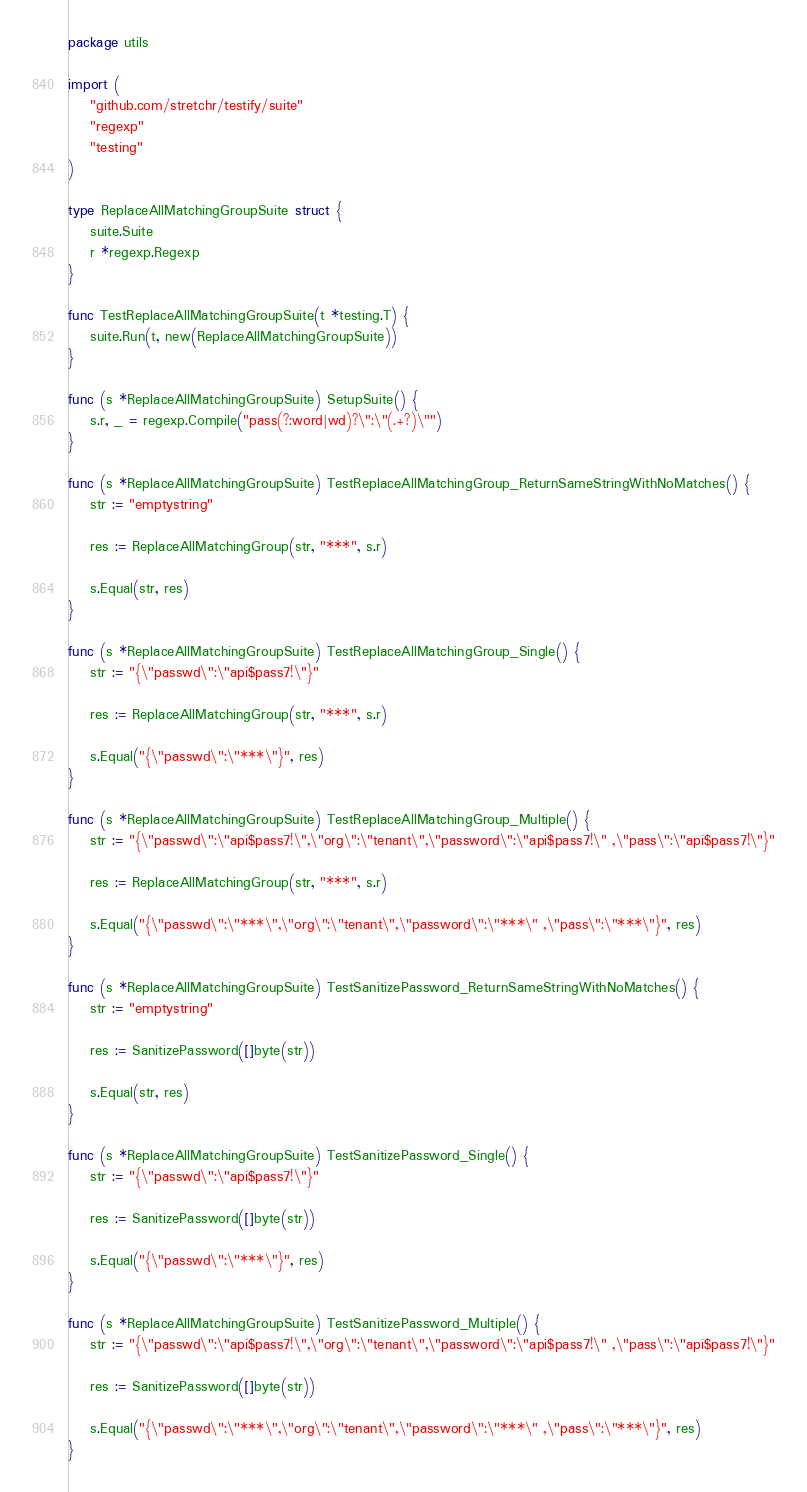<code> <loc_0><loc_0><loc_500><loc_500><_Go_>package utils

import (
	"github.com/stretchr/testify/suite"
	"regexp"
	"testing"
)

type ReplaceAllMatchingGroupSuite struct {
	suite.Suite
	r *regexp.Regexp
}

func TestReplaceAllMatchingGroupSuite(t *testing.T) {
	suite.Run(t, new(ReplaceAllMatchingGroupSuite))
}

func (s *ReplaceAllMatchingGroupSuite) SetupSuite() {
	s.r, _ = regexp.Compile("pass(?:word|wd)?\":\"(.+?)\"")
}

func (s *ReplaceAllMatchingGroupSuite) TestReplaceAllMatchingGroup_ReturnSameStringWithNoMatches() {
	str := "emptystring"

	res := ReplaceAllMatchingGroup(str, "***", s.r)

	s.Equal(str, res)
}

func (s *ReplaceAllMatchingGroupSuite) TestReplaceAllMatchingGroup_Single() {
	str := "{\"passwd\":\"api$pass7!\"}"

	res := ReplaceAllMatchingGroup(str, "***", s.r)

	s.Equal("{\"passwd\":\"***\"}", res)
}

func (s *ReplaceAllMatchingGroupSuite) TestReplaceAllMatchingGroup_Multiple() {
	str := "{\"passwd\":\"api$pass7!\",\"org\":\"tenant\",\"password\":\"api$pass7!\" ,\"pass\":\"api$pass7!\"}"

	res := ReplaceAllMatchingGroup(str, "***", s.r)

	s.Equal("{\"passwd\":\"***\",\"org\":\"tenant\",\"password\":\"***\" ,\"pass\":\"***\"}", res)
}

func (s *ReplaceAllMatchingGroupSuite) TestSanitizePassword_ReturnSameStringWithNoMatches() {
	str := "emptystring"

	res := SanitizePassword([]byte(str))

	s.Equal(str, res)
}

func (s *ReplaceAllMatchingGroupSuite) TestSanitizePassword_Single() {
	str := "{\"passwd\":\"api$pass7!\"}"

	res := SanitizePassword([]byte(str))

	s.Equal("{\"passwd\":\"***\"}", res)
}

func (s *ReplaceAllMatchingGroupSuite) TestSanitizePassword_Multiple() {
	str := "{\"passwd\":\"api$pass7!\",\"org\":\"tenant\",\"password\":\"api$pass7!\" ,\"pass\":\"api$pass7!\"}"

	res := SanitizePassword([]byte(str))

	s.Equal("{\"passwd\":\"***\",\"org\":\"tenant\",\"password\":\"***\" ,\"pass\":\"***\"}", res)
}
</code> 